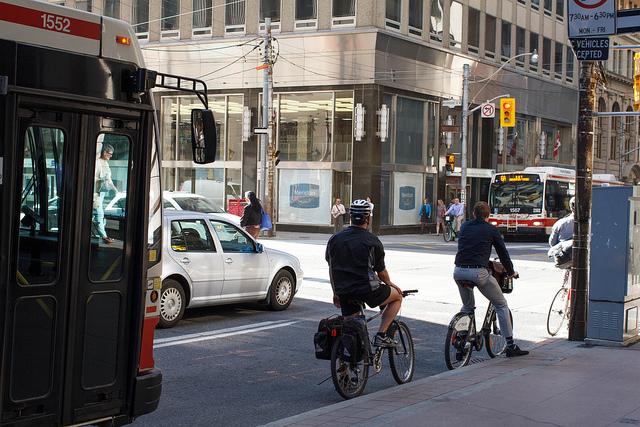Is this photo outdoors?
Keep it brief. Yes. How many modes of transportation are visible?
Give a very brief answer. 3. Why has traffic stopped?
Be succinct. Red light. 